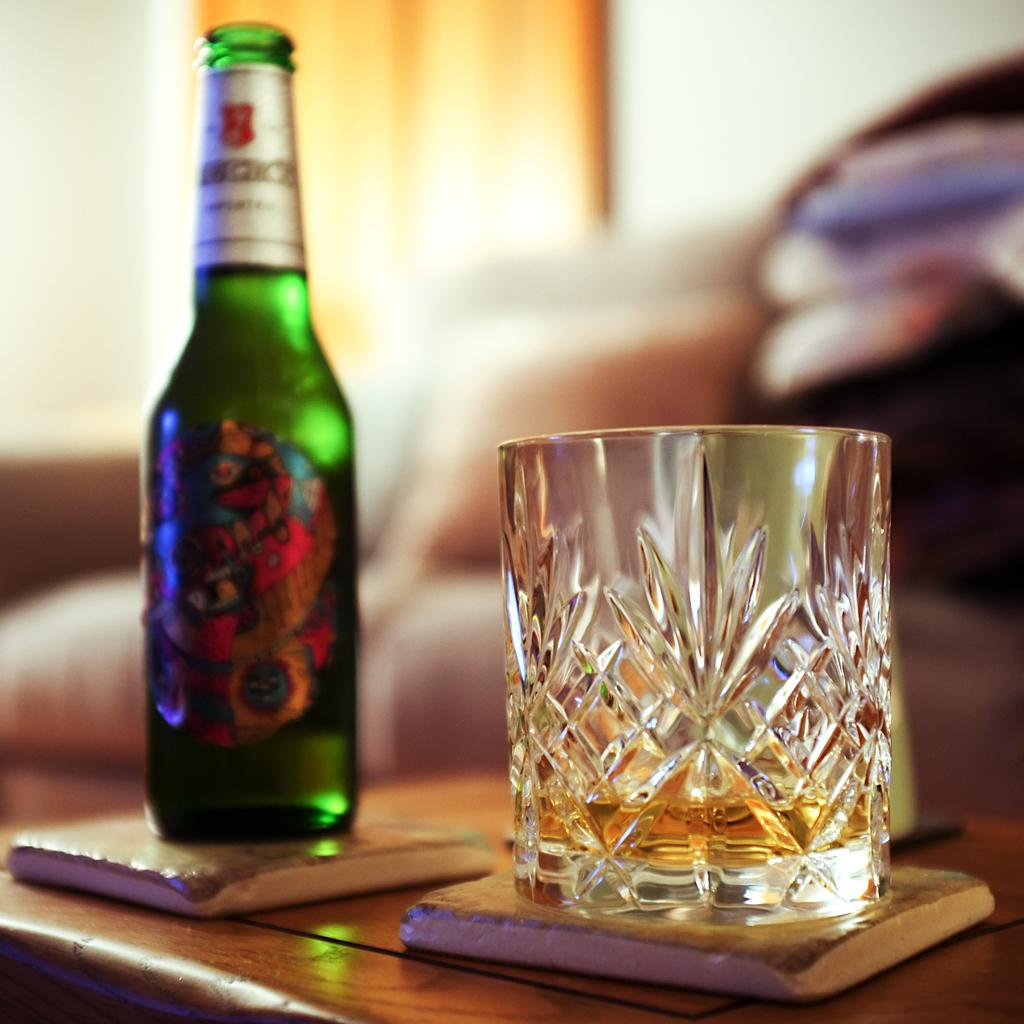<image>
Describe the image concisely. A glass of alcohol sitting next to an open bottle of beer with the word "And" visible on the label. 